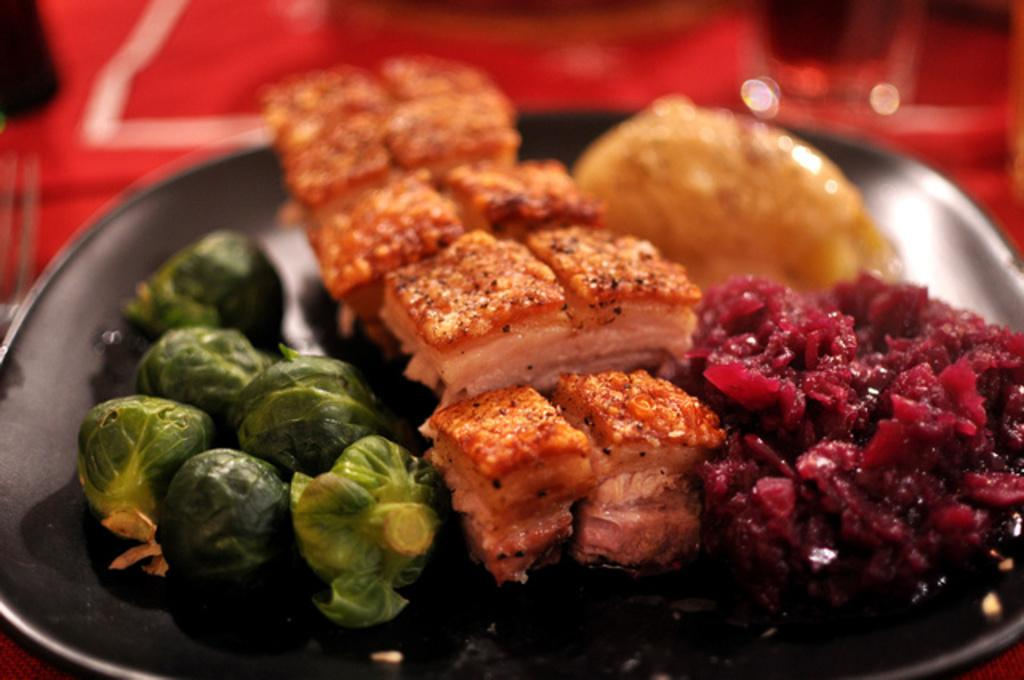What object is present on the plate in the image? There is a food item on the plate in the image. Can you describe the background of the image? The background of the image is blurred. What type of plastic chain is holding the food item on the plate? There is no plastic chain present in the image; the food item is simply on the plate. Where is the pail located in the image? There is no pail present in the image. 